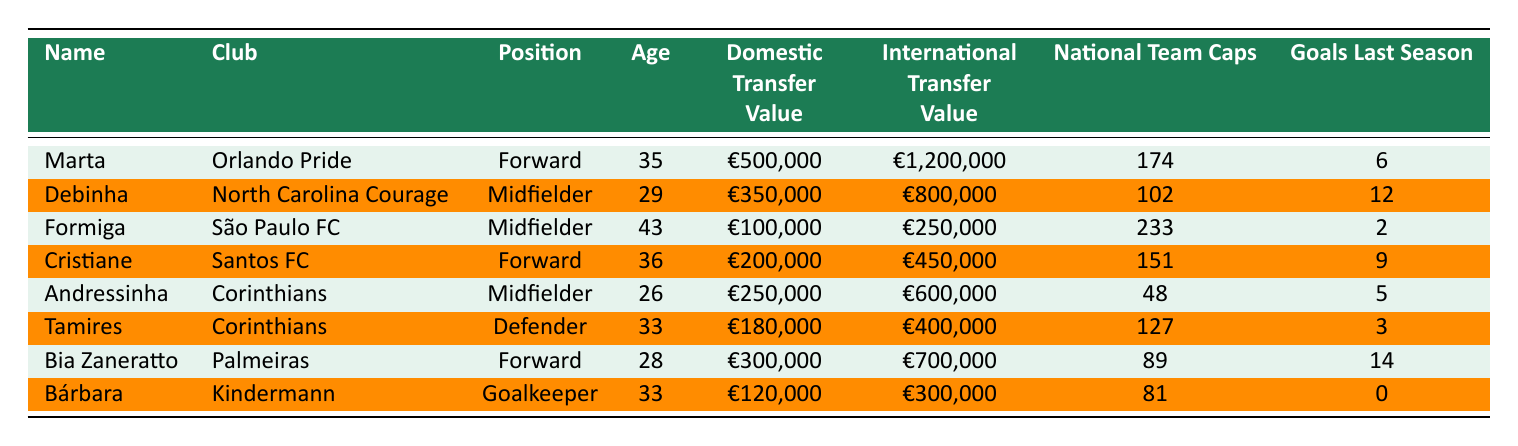What is Marta's international transfer value? Referring to the table, Marta's international transfer value is listed as €1,200,000.
Answer: €1,200,000 Who has the lowest domestic transfer value among the players listed? The table shows that Formiga has the lowest domestic transfer value, which is €100,000.
Answer: Formiga What is the total number of goals scored by Bia Zaneratto and Debinha last season? Bia Zaneratto scored 14 goals and Debinha scored 12 goals. Adding these gives 14 + 12 = 26 goals.
Answer: 26 Is Andressinha older than Tamires? Andressinha is 26 years old, while Tamires is 33 years old. Thus, Andressinha is not older than Tamires.
Answer: No What is the average international transfer value of the players listed? To find the average, add the international transfer values: €1,200,000 + €800,000 + €250,000 + €450,000 + €600,000 + €400,000 + €700,000 + €300,000 = €4,650,000. There are 8 players, so the average is €4,650,000 / 8 = €581,250.
Answer: €581,250 How many national team caps does the oldest player in the table have? The oldest player is Formiga, who is 43 years old, and she has 233 national team caps as listed in the table.
Answer: 233 What percentage of Marta's domestic transfer value is her international transfer value? Marta's domestic transfer value is €500,000 and her international transfer value is €1,200,000. The percentage can be calculated as (€1,200,000 / €500,000) * 100 = 240%.
Answer: 240% Which player has scored more goals last season, Marta or Cristiane? Marta scored 6 goals last season while Cristiane scored 9 goals. Since 9 is greater than 6, Cristiane scored more goals.
Answer: Cristiane 